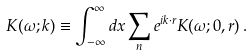Convert formula to latex. <formula><loc_0><loc_0><loc_500><loc_500>K ( \omega ; { k } ) \equiv \int _ { - \infty } ^ { \infty } d x \sum _ { n } e ^ { i { k } \cdot { r } } K ( \omega ; { 0 } , { r } ) \, .</formula> 